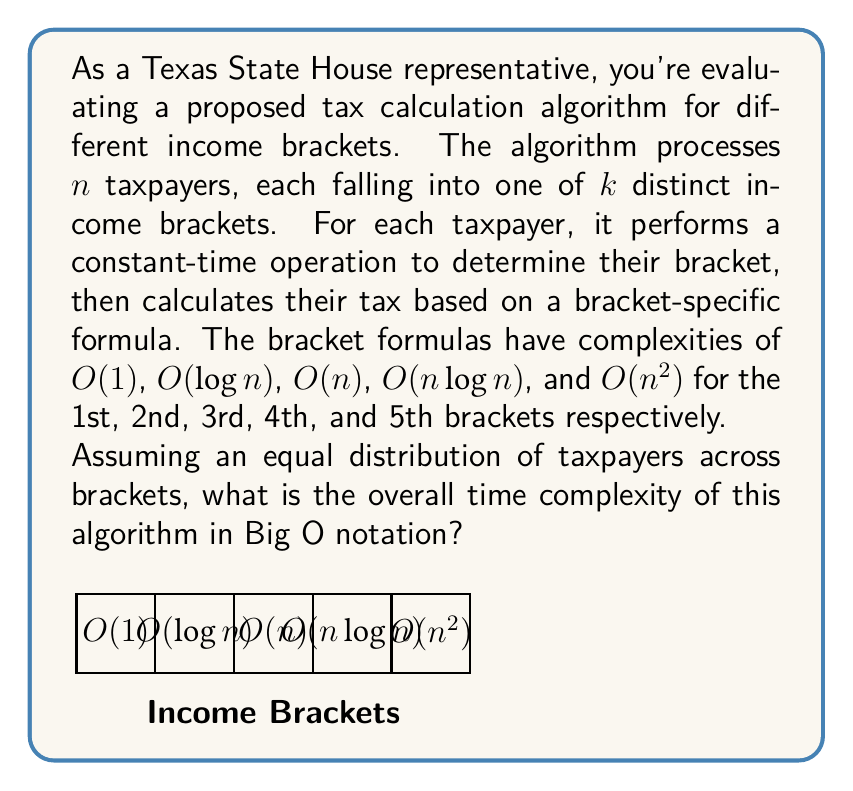Provide a solution to this math problem. Let's approach this step-by-step:

1) We have $n$ taxpayers distributed equally among $k=5$ brackets. So, each bracket contains $\frac{n}{5}$ taxpayers.

2) For each taxpayer, we perform:
   a) A constant-time operation to determine their bracket: $O(1)$
   b) The bracket-specific calculation

3) The time complexity for each bracket is:
   Bracket 1: $\frac{n}{5} \cdot O(1) = O(n)$
   Bracket 2: $\frac{n}{5} \cdot O(\log n) = O(n \log n)$
   Bracket 3: $\frac{n}{5} \cdot O(n) = O(n^2)$
   Bracket 4: $\frac{n}{5} \cdot O(n \log n) = O(n^2 \log n)$
   Bracket 5: $\frac{n}{5} \cdot O(n^2) = O(n^3)$

4) The overall time complexity is the sum of these individual complexities:
   $O(n) + O(n \log n) + O(n^2) + O(n^2 \log n) + O(n^3)$

5) In Big O notation, we only consider the dominant term. Here, the dominant term is $O(n^3)$.

Therefore, the overall time complexity of the algorithm is $O(n^3)$.
Answer: $O(n^3)$ 